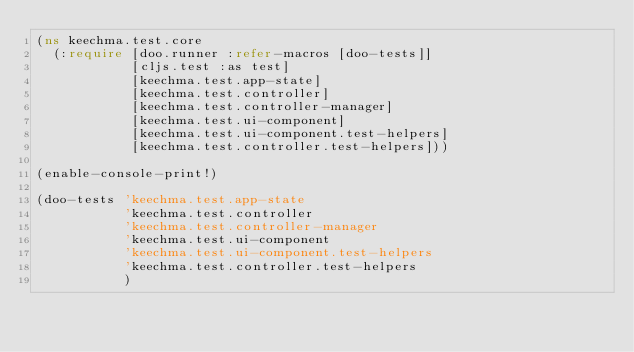Convert code to text. <code><loc_0><loc_0><loc_500><loc_500><_Clojure_>(ns keechma.test.core
  (:require [doo.runner :refer-macros [doo-tests]]
            [cljs.test :as test]
            [keechma.test.app-state]
            [keechma.test.controller]
            [keechma.test.controller-manager]
            [keechma.test.ui-component]
            [keechma.test.ui-component.test-helpers]
            [keechma.test.controller.test-helpers]))

(enable-console-print!)

(doo-tests 'keechma.test.app-state
           'keechma.test.controller
           'keechma.test.controller-manager
           'keechma.test.ui-component
           'keechma.test.ui-component.test-helpers
           'keechma.test.controller.test-helpers
           )
</code> 